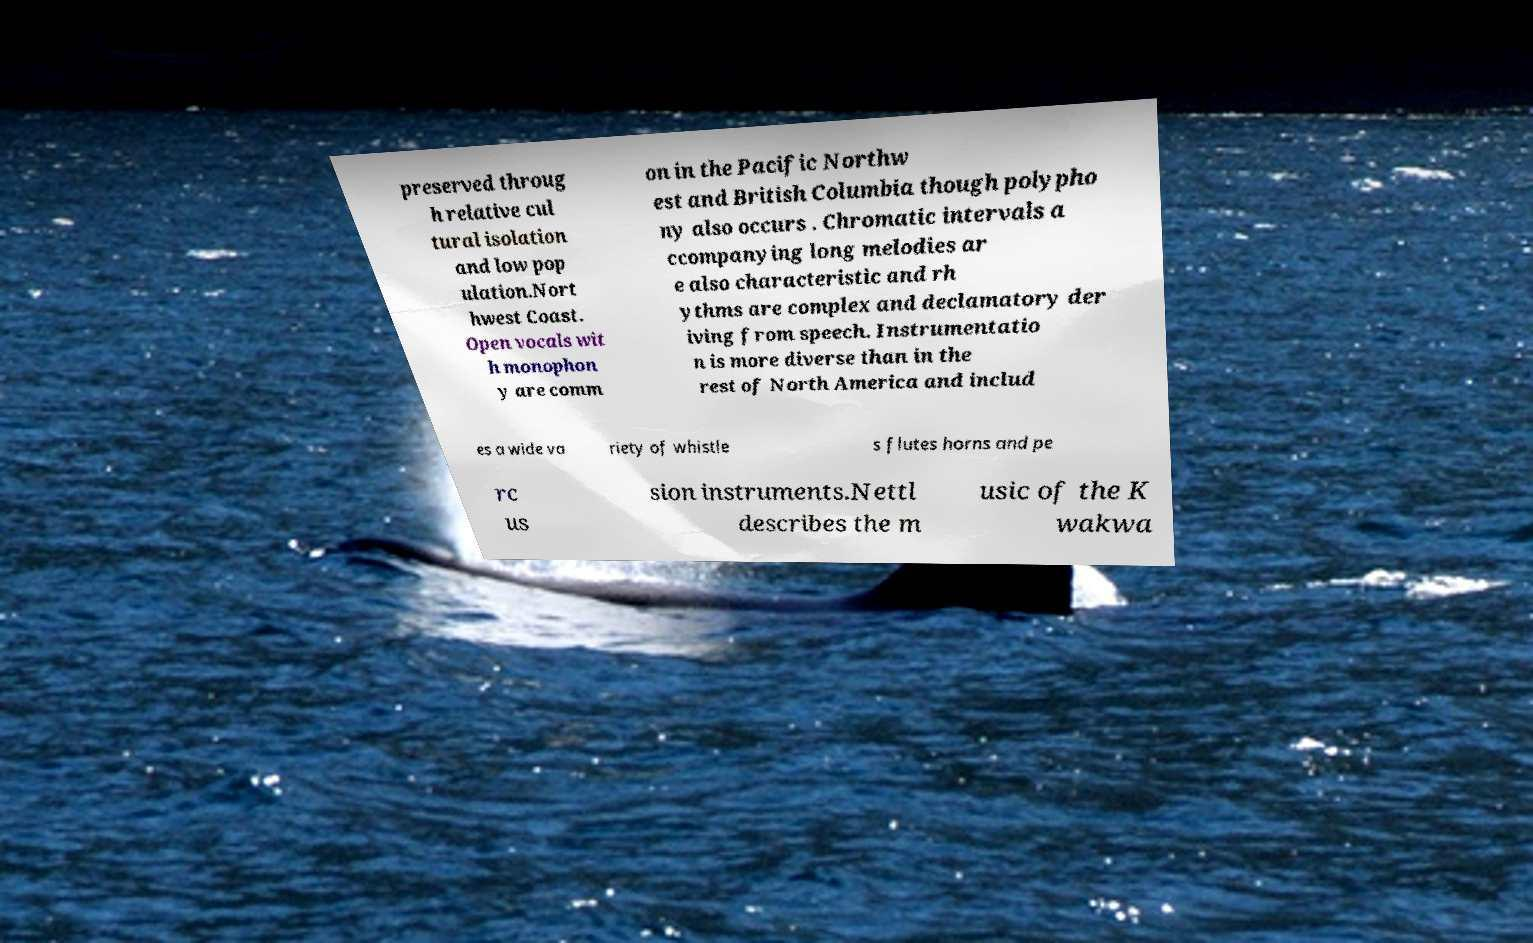Could you extract and type out the text from this image? preserved throug h relative cul tural isolation and low pop ulation.Nort hwest Coast. Open vocals wit h monophon y are comm on in the Pacific Northw est and British Columbia though polypho ny also occurs . Chromatic intervals a ccompanying long melodies ar e also characteristic and rh ythms are complex and declamatory der iving from speech. Instrumentatio n is more diverse than in the rest of North America and includ es a wide va riety of whistle s flutes horns and pe rc us sion instruments.Nettl describes the m usic of the K wakwa 